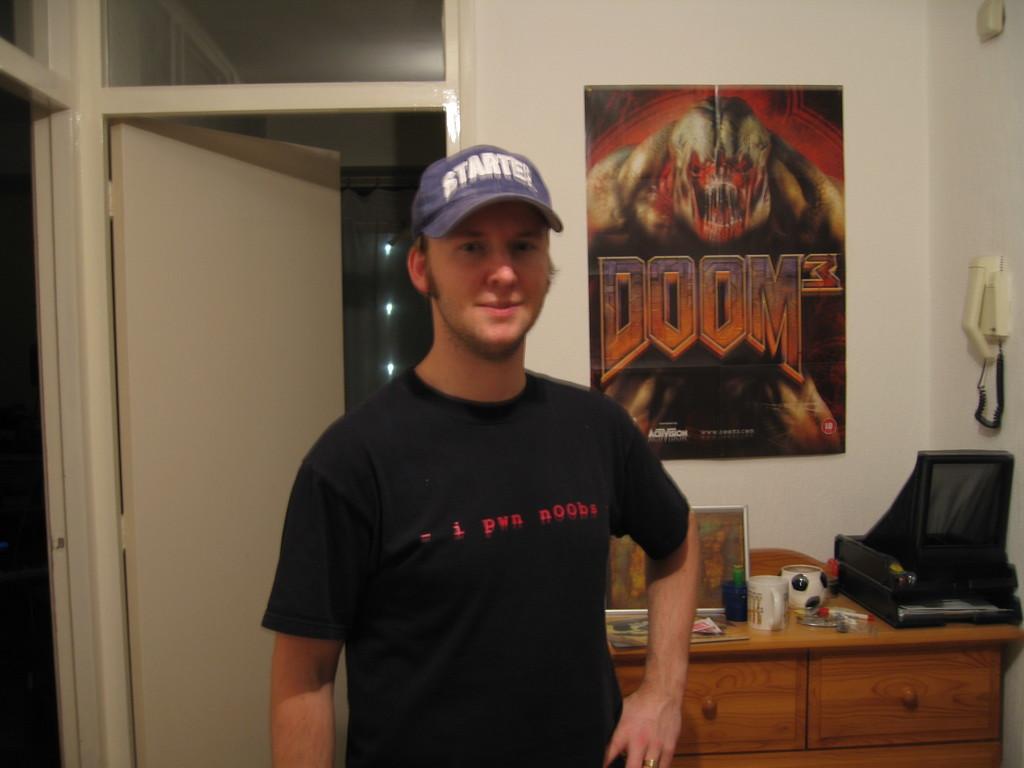What does his hat say?
Keep it short and to the point. Starter. 